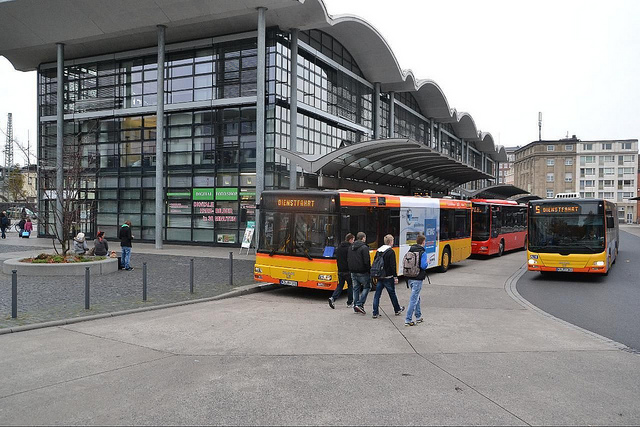What types of transportation modes can be inferred from this image besides the buses? Aside from the buses, pedestrian movement is evident, suggesting walkability in the area. Furthermore, the layout of the station suggests that it may accommodate other forms of public transportation, such as trams or trains, although they are not visible in the photo. 